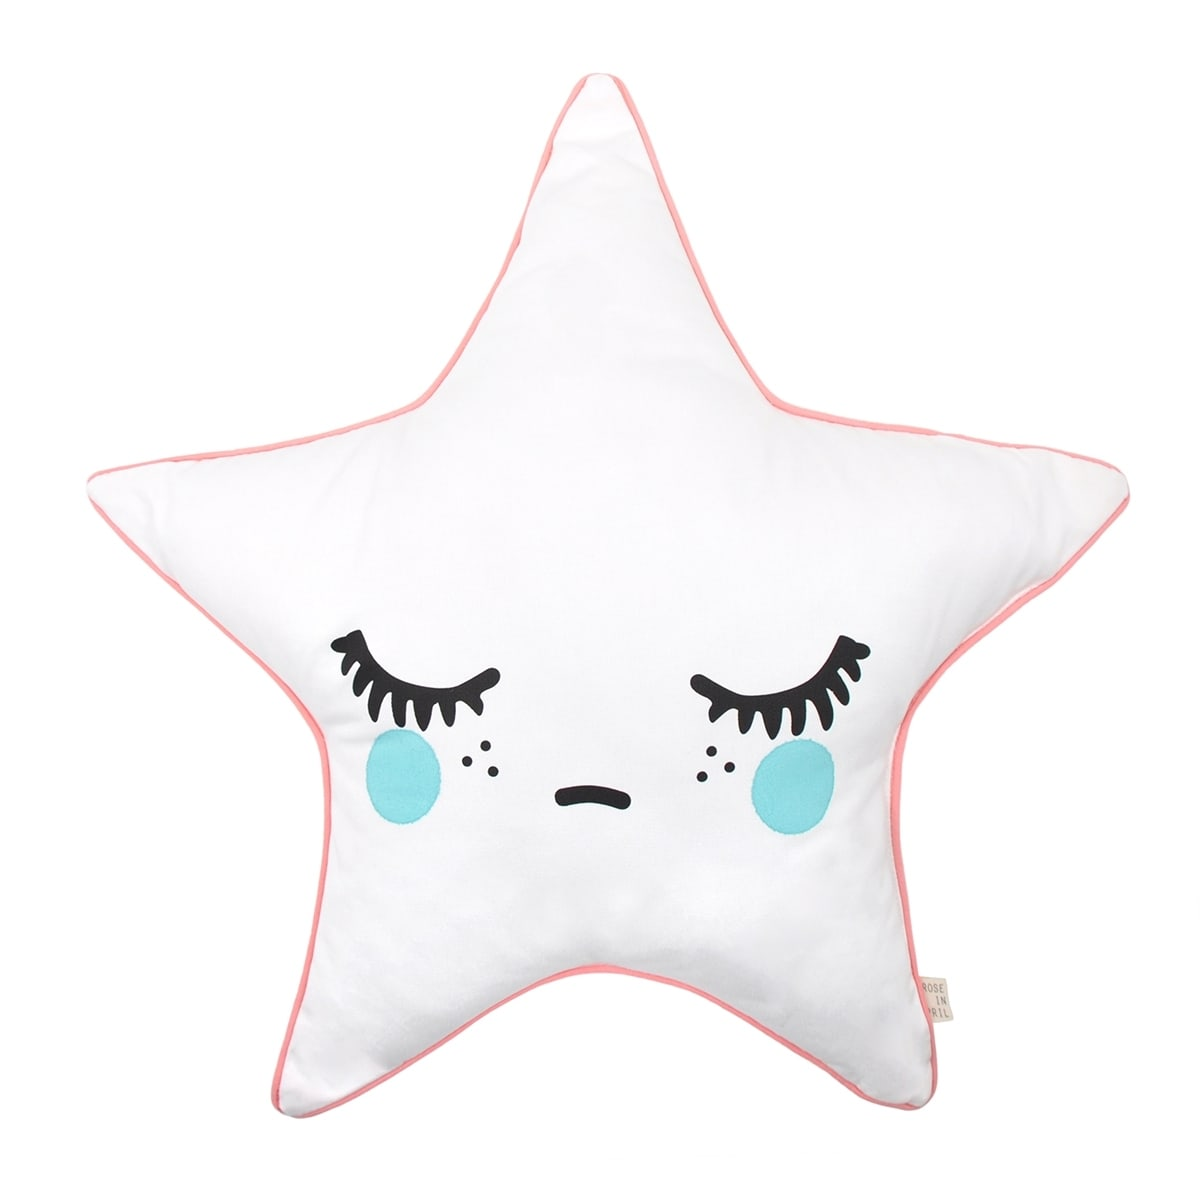You found this pillow in an antique shop. What could be its quirky backstory? Nestled in a corner of an enchanting antique shop, this star-shaped pillow has a quirky backstory. Originally crafted by a grandmother with a penchant for celestial designs, it was part of a limited collection celebrated for its soothing aura. Over the decades, this very pillow traveled through various owners, each adding their touch of magic. It spent years in a storyteller's attic, serving as inspiration for countless children’s tales. Then, it found its way to a young astronomer’s study, providing comfort during nights spent mapping the stars. Finally, it was discovered by an artist who integrated it into whimsical art installations before placing it in the charming antique shop where it now waits, ready to spark new dreams and adventures in its next home. 